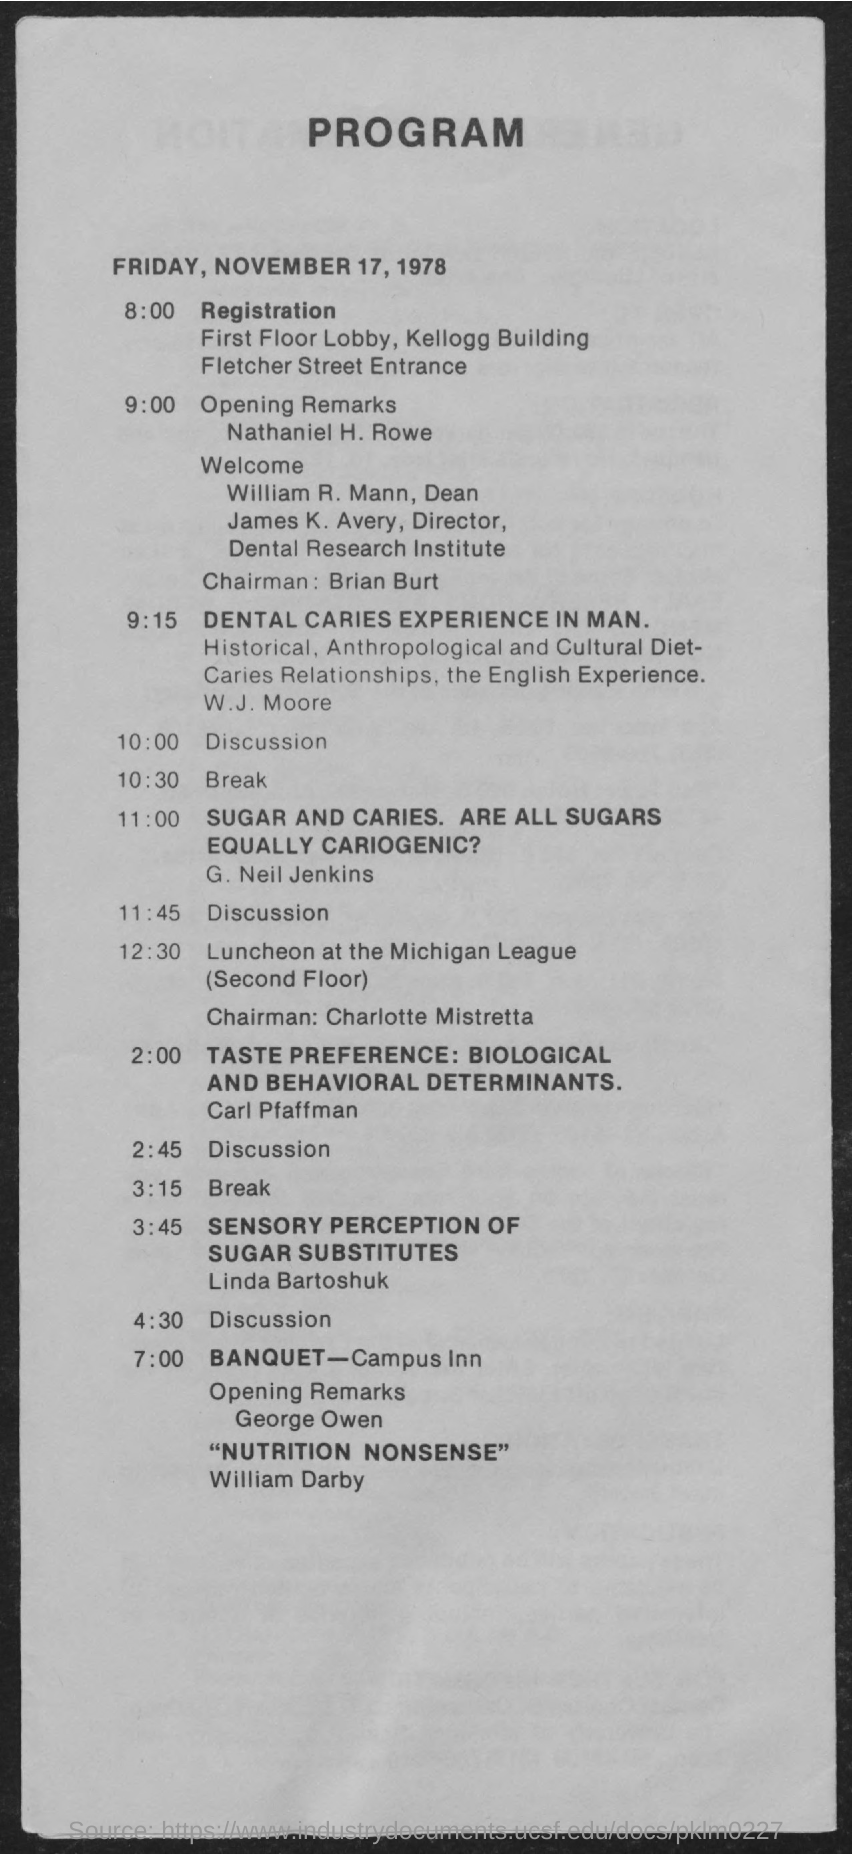What is the date on the document?
Give a very brief answer. Friday, November 17, 1978. When is the Registration?
Make the answer very short. 8:00. 